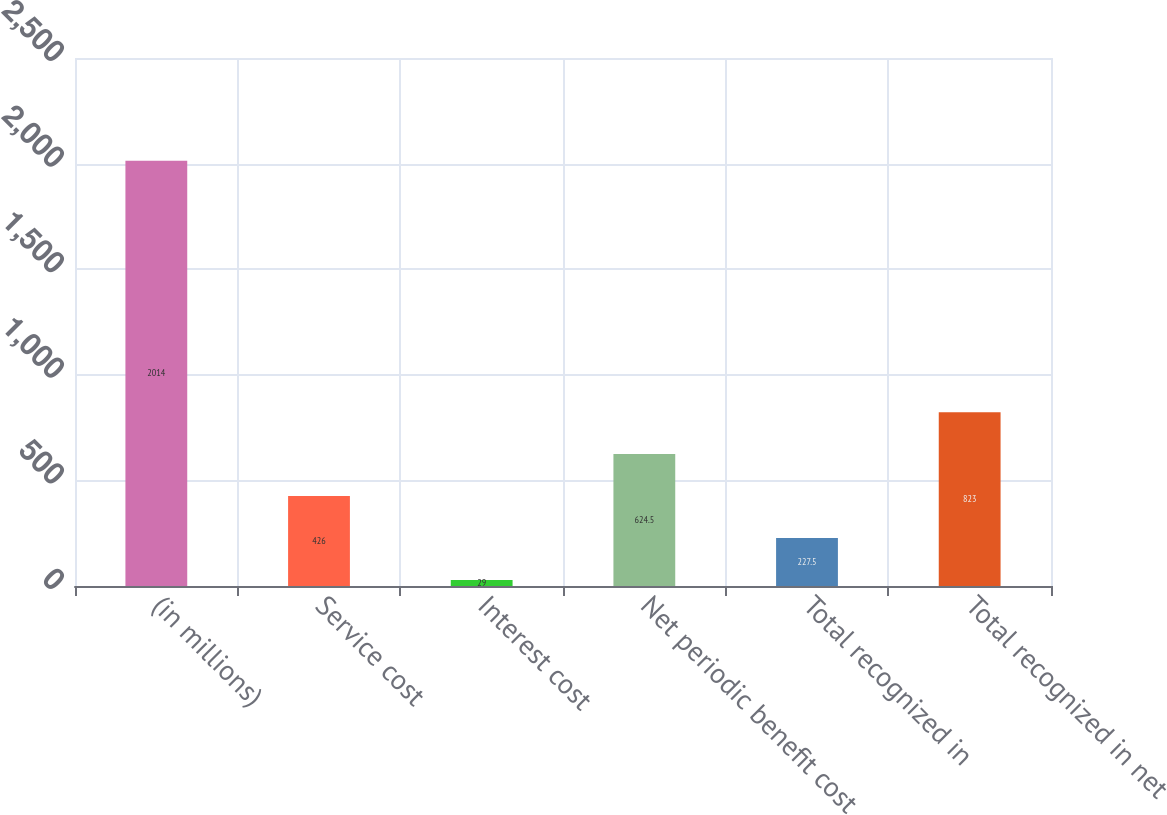Convert chart. <chart><loc_0><loc_0><loc_500><loc_500><bar_chart><fcel>(in millions)<fcel>Service cost<fcel>Interest cost<fcel>Net periodic benefit cost<fcel>Total recognized in<fcel>Total recognized in net<nl><fcel>2014<fcel>426<fcel>29<fcel>624.5<fcel>227.5<fcel>823<nl></chart> 